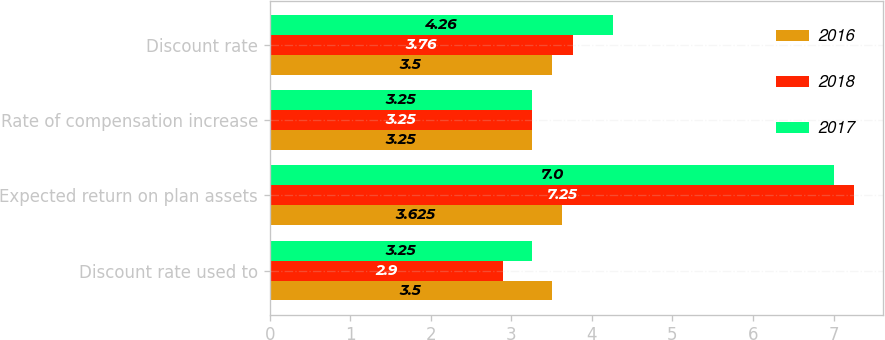<chart> <loc_0><loc_0><loc_500><loc_500><stacked_bar_chart><ecel><fcel>Discount rate used to<fcel>Expected return on plan assets<fcel>Rate of compensation increase<fcel>Discount rate<nl><fcel>2016<fcel>3.5<fcel>3.625<fcel>3.25<fcel>3.5<nl><fcel>2018<fcel>2.9<fcel>7.25<fcel>3.25<fcel>3.76<nl><fcel>2017<fcel>3.25<fcel>7<fcel>3.25<fcel>4.26<nl></chart> 